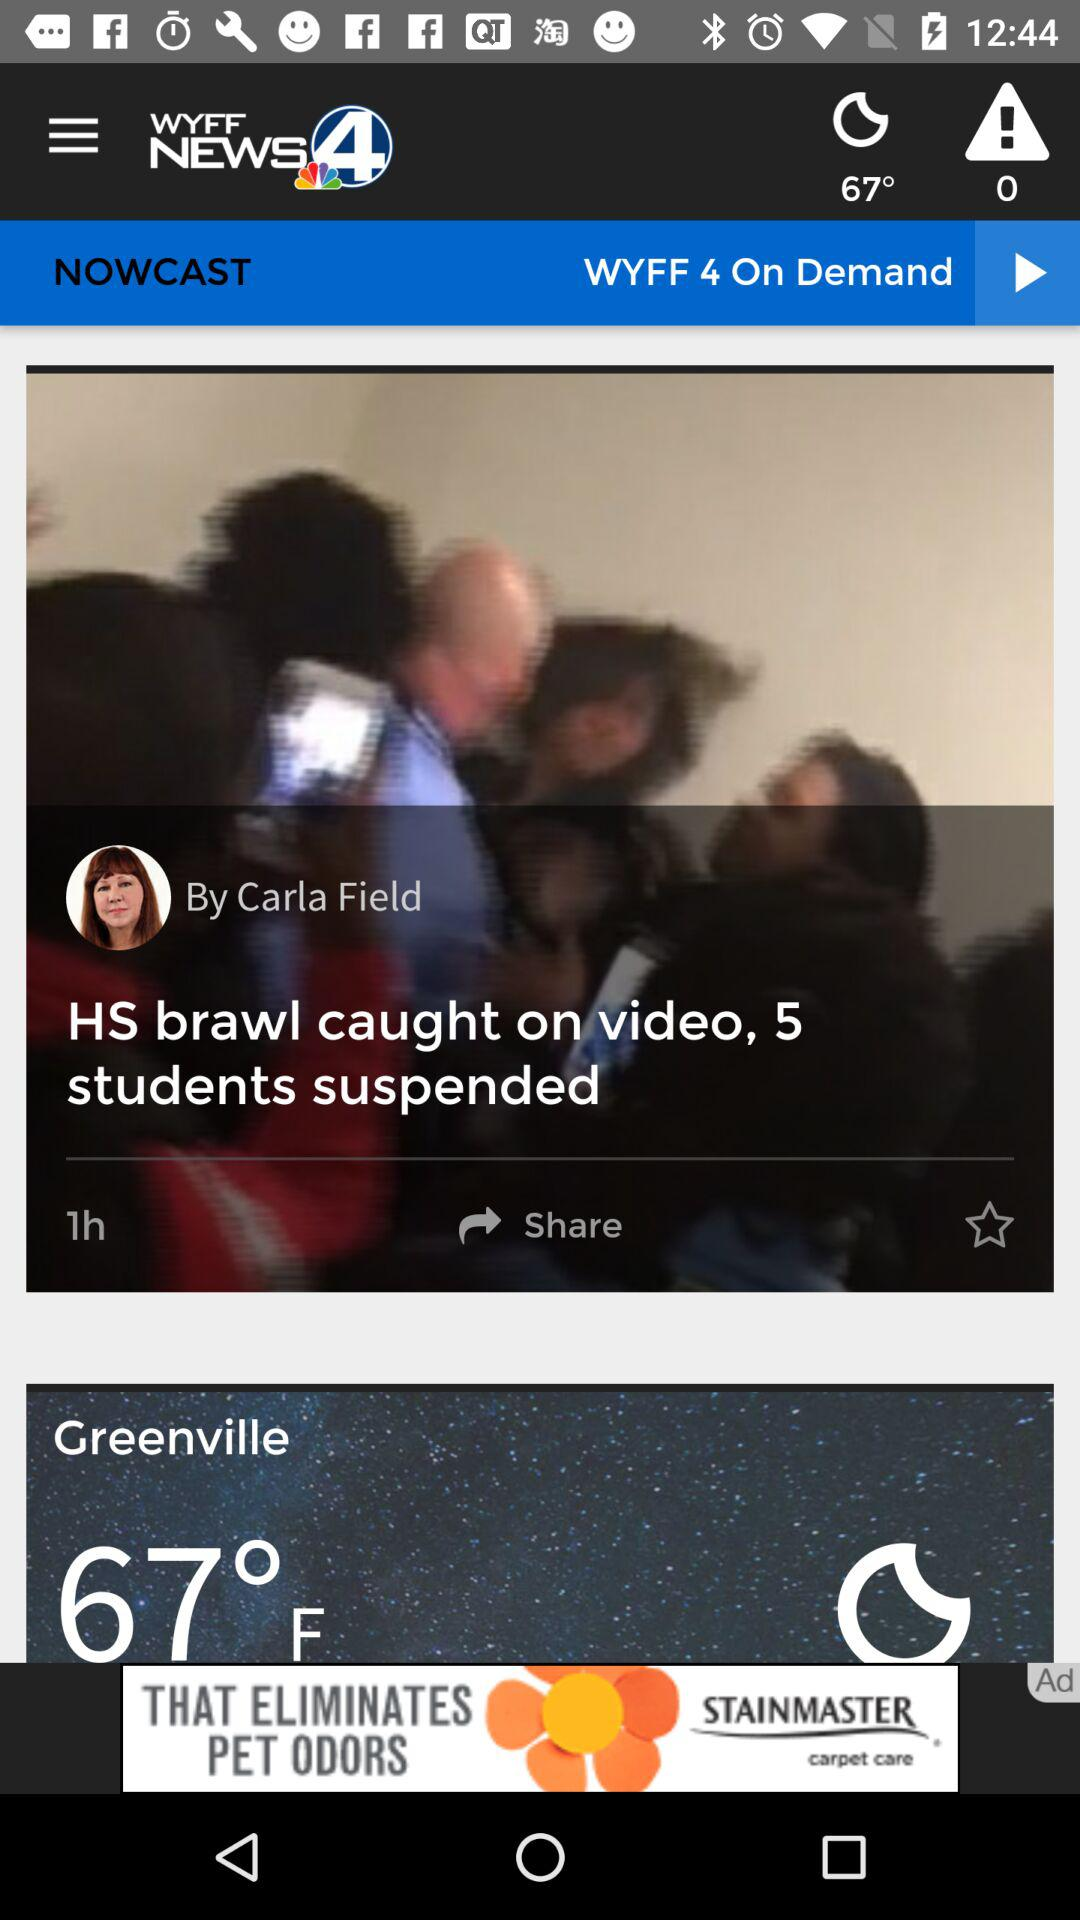How many hours ago did Carla Field update a post? Carla Field updated a post 1 hour ago. 